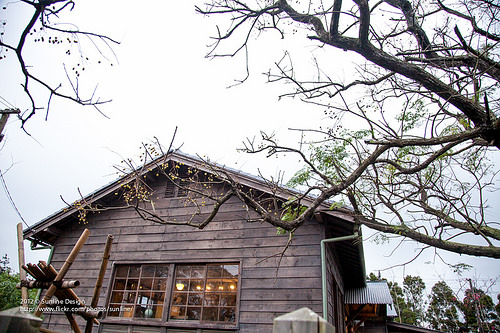<image>
Is the design in front of the house? Yes. The design is positioned in front of the house, appearing closer to the camera viewpoint. 